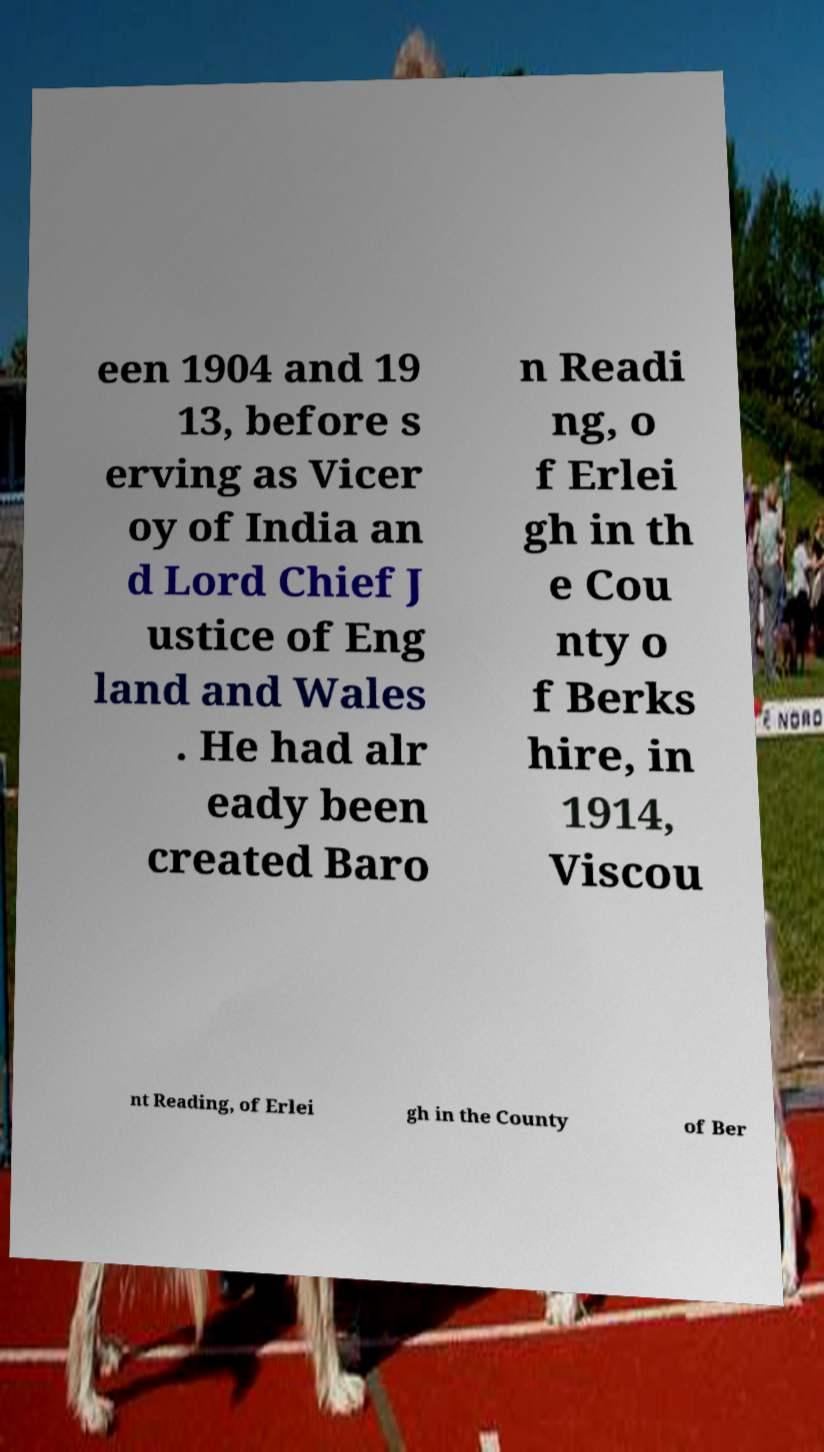Please identify and transcribe the text found in this image. een 1904 and 19 13, before s erving as Vicer oy of India an d Lord Chief J ustice of Eng land and Wales . He had alr eady been created Baro n Readi ng, o f Erlei gh in th e Cou nty o f Berks hire, in 1914, Viscou nt Reading, of Erlei gh in the County of Ber 